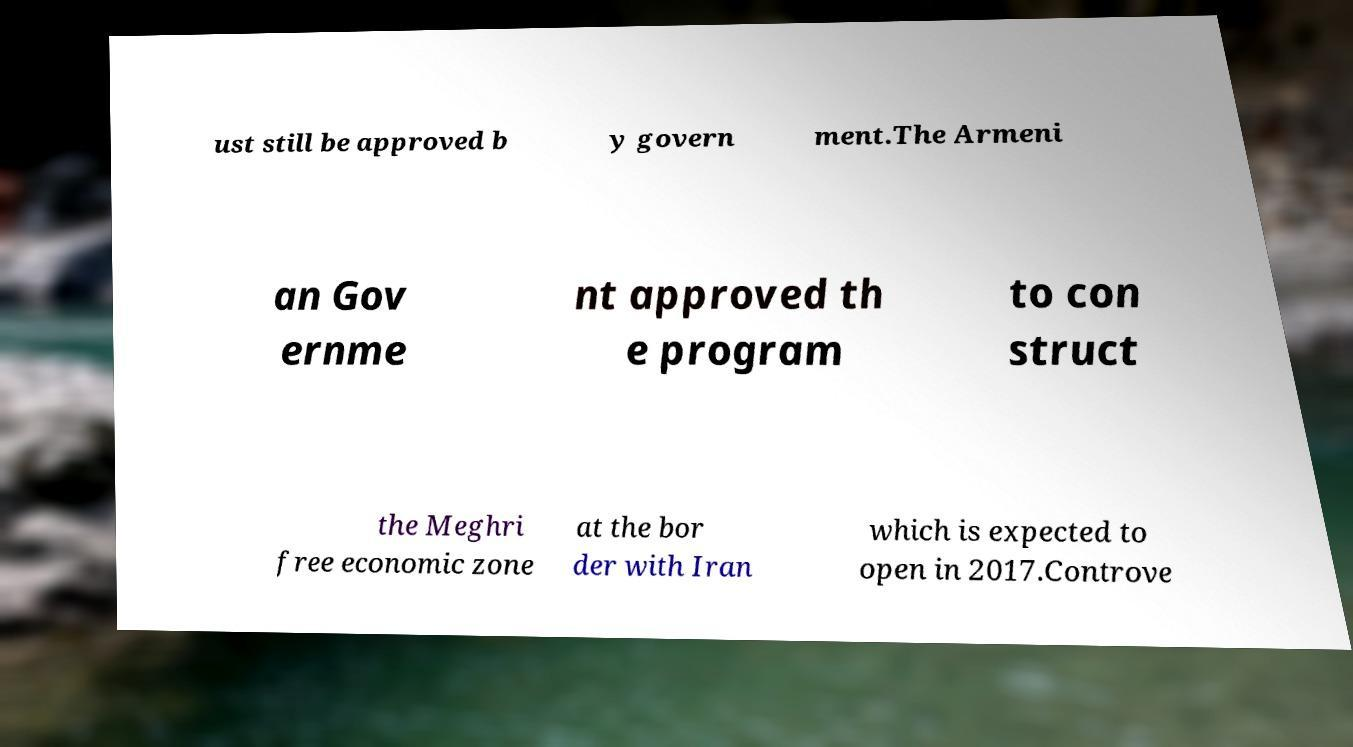Could you extract and type out the text from this image? ust still be approved b y govern ment.The Armeni an Gov ernme nt approved th e program to con struct the Meghri free economic zone at the bor der with Iran which is expected to open in 2017.Controve 